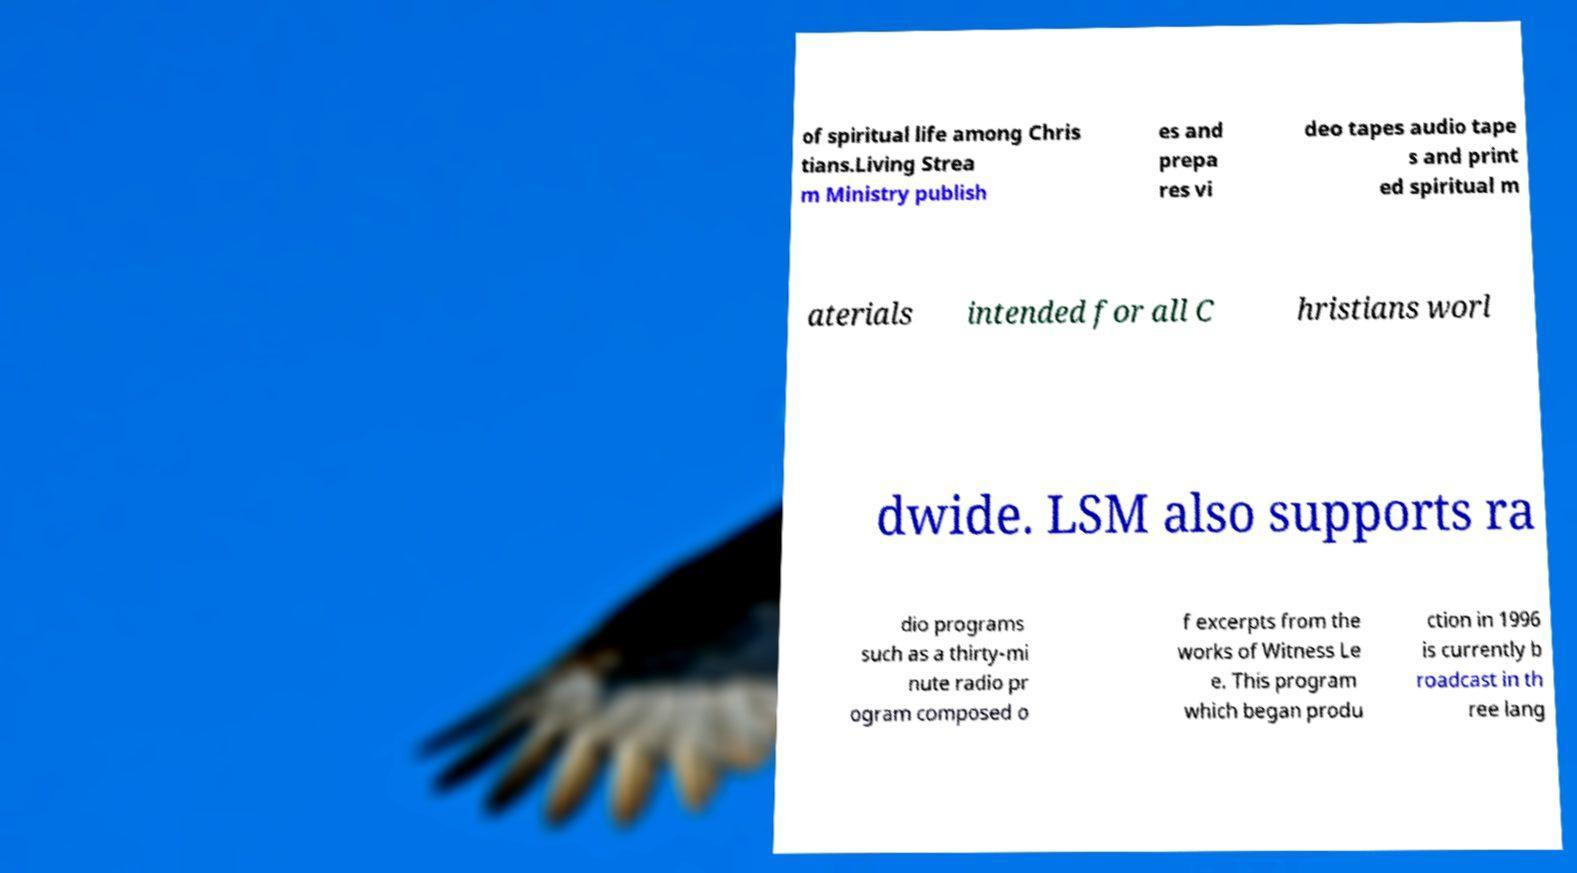There's text embedded in this image that I need extracted. Can you transcribe it verbatim? of spiritual life among Chris tians.Living Strea m Ministry publish es and prepa res vi deo tapes audio tape s and print ed spiritual m aterials intended for all C hristians worl dwide. LSM also supports ra dio programs such as a thirty-mi nute radio pr ogram composed o f excerpts from the works of Witness Le e. This program which began produ ction in 1996 is currently b roadcast in th ree lang 